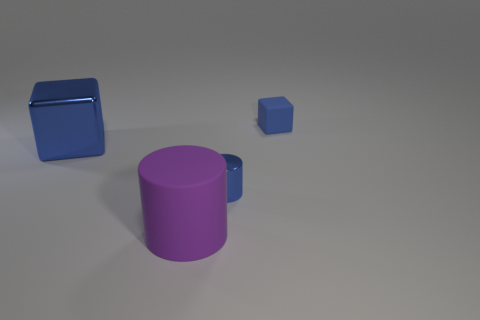How many objects can you see in the image? There are three objects visible in the image: a large purple cylinder, a smaller blue cube, and a metallic object which appears to be another smaller cube. 